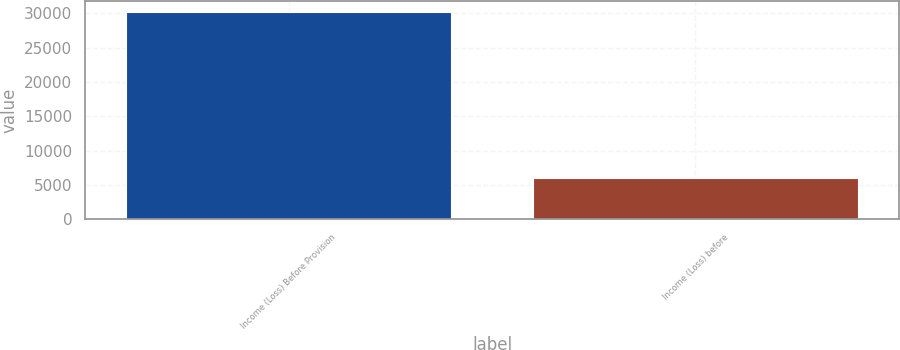Convert chart. <chart><loc_0><loc_0><loc_500><loc_500><bar_chart><fcel>Income (Loss) Before Provision<fcel>Income (Loss) before<nl><fcel>30219<fcel>5981<nl></chart> 